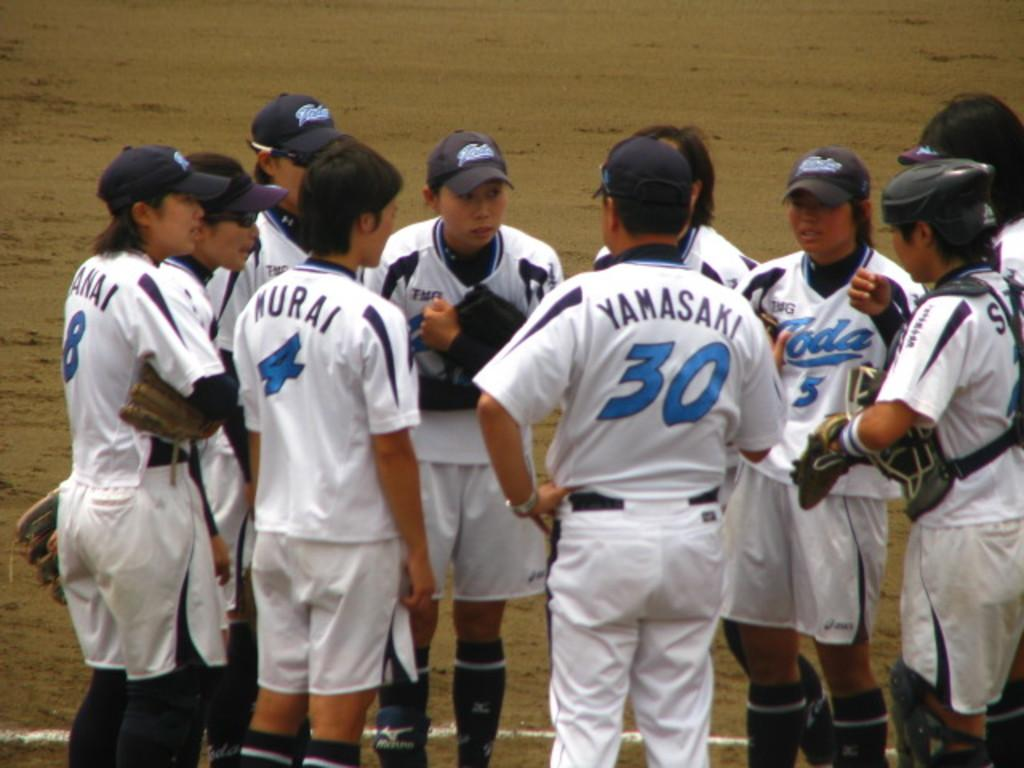Provide a one-sentence caption for the provided image. The athletic player Yamasaki is surrounded by his teammates on the playing field.. 